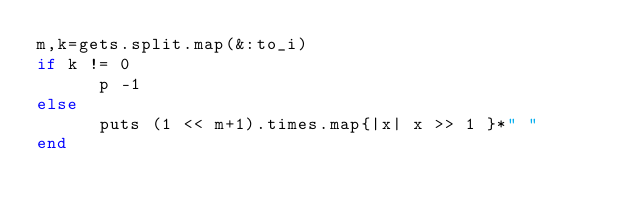<code> <loc_0><loc_0><loc_500><loc_500><_Ruby_>m,k=gets.split.map(&:to_i)
if k != 0 
	  p -1
else
	  puts (1 << m+1).times.map{|x| x >> 1 }*" "
end
</code> 